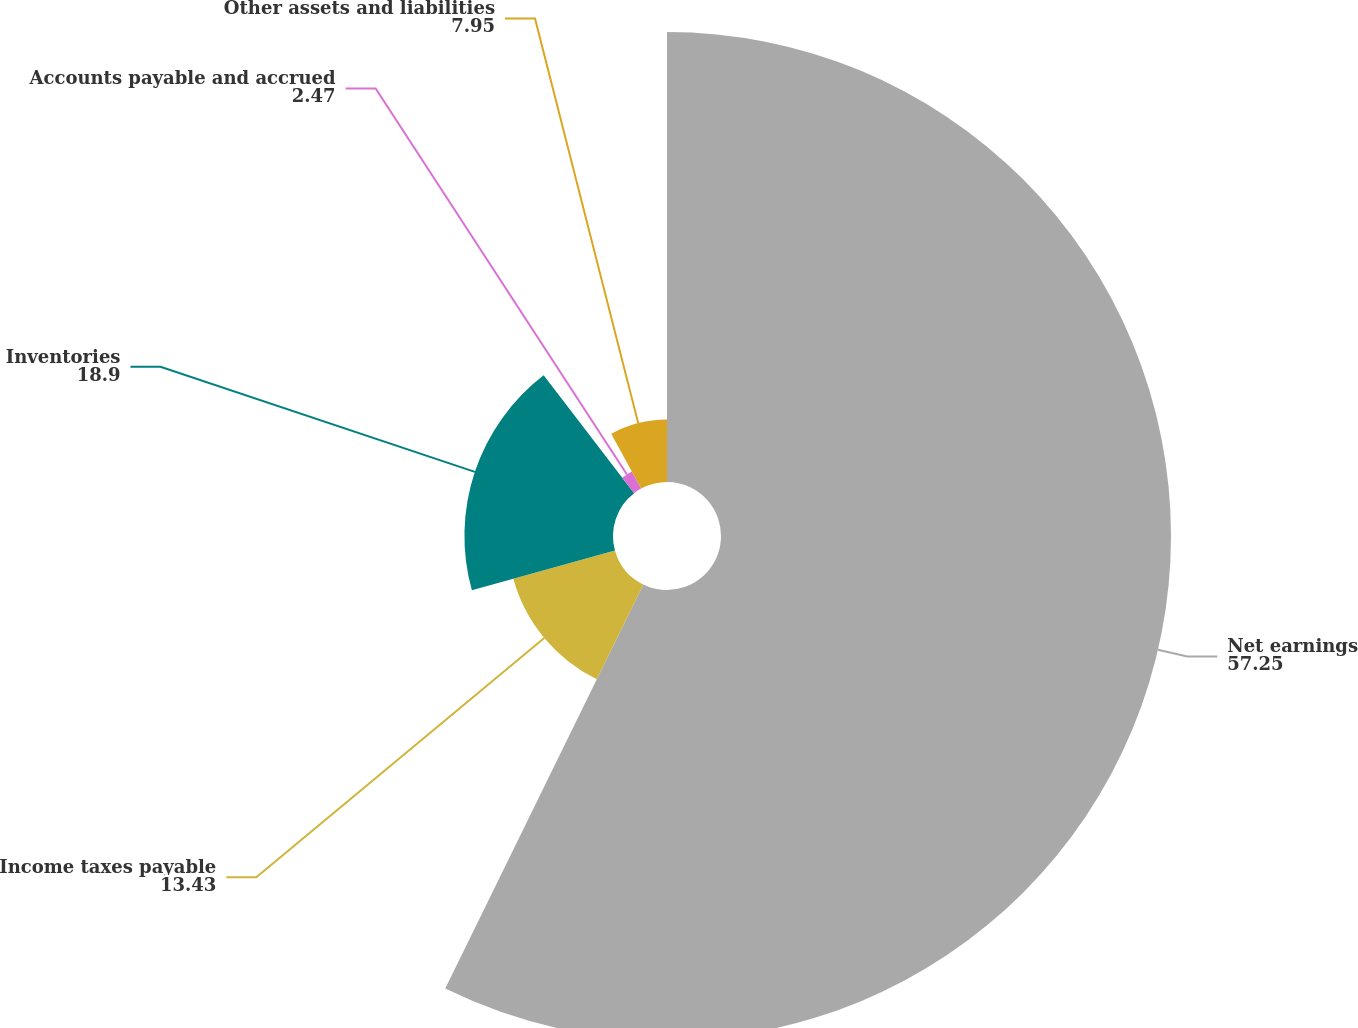Convert chart to OTSL. <chart><loc_0><loc_0><loc_500><loc_500><pie_chart><fcel>Net earnings<fcel>Income taxes payable<fcel>Inventories<fcel>Accounts payable and accrued<fcel>Other assets and liabilities<nl><fcel>57.25%<fcel>13.43%<fcel>18.9%<fcel>2.47%<fcel>7.95%<nl></chart> 